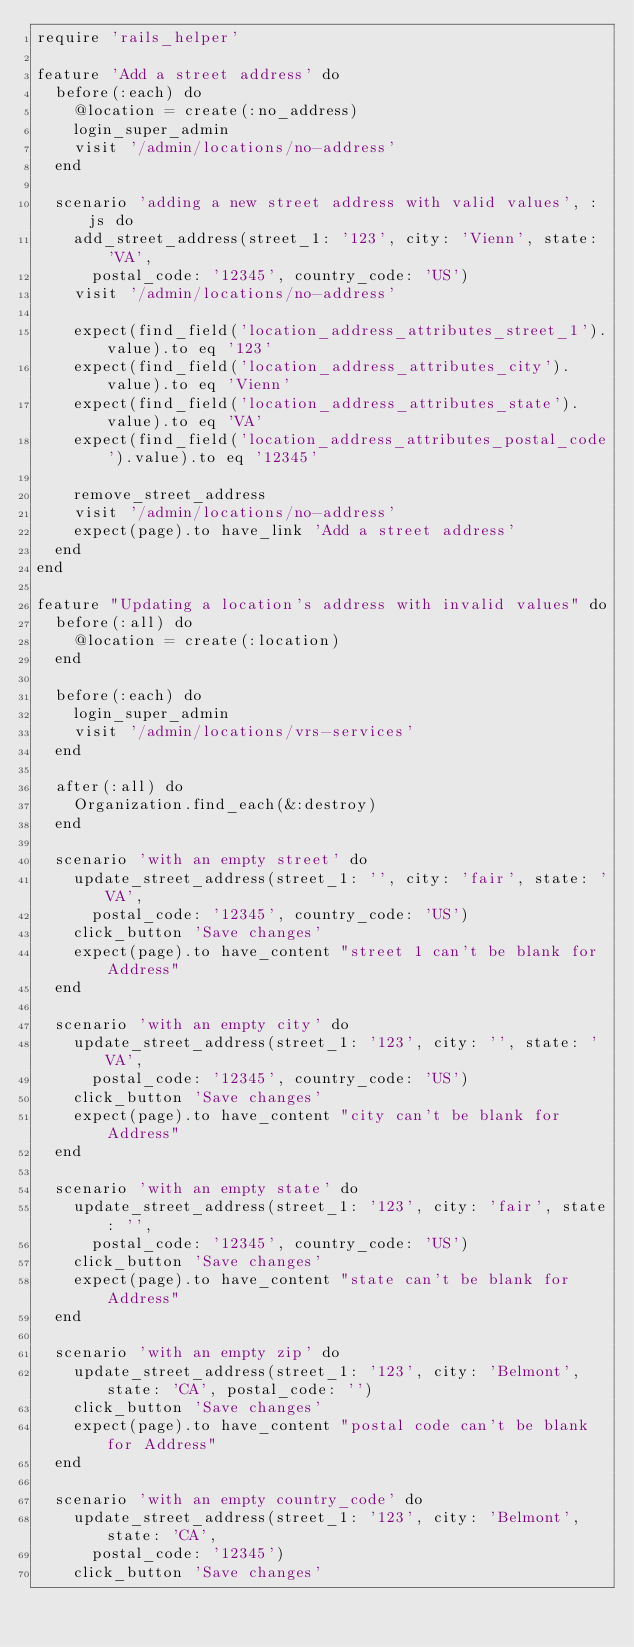Convert code to text. <code><loc_0><loc_0><loc_500><loc_500><_Ruby_>require 'rails_helper'

feature 'Add a street address' do
  before(:each) do
    @location = create(:no_address)
    login_super_admin
    visit '/admin/locations/no-address'
  end

  scenario 'adding a new street address with valid values', :js do
    add_street_address(street_1: '123', city: 'Vienn', state: 'VA',
      postal_code: '12345', country_code: 'US')
    visit '/admin/locations/no-address'

    expect(find_field('location_address_attributes_street_1').value).to eq '123'
    expect(find_field('location_address_attributes_city').value).to eq 'Vienn'
    expect(find_field('location_address_attributes_state').value).to eq 'VA'
    expect(find_field('location_address_attributes_postal_code').value).to eq '12345'

    remove_street_address
    visit '/admin/locations/no-address'
    expect(page).to have_link 'Add a street address'
  end
end

feature "Updating a location's address with invalid values" do
  before(:all) do
    @location = create(:location)
  end

  before(:each) do
    login_super_admin
    visit '/admin/locations/vrs-services'
  end

  after(:all) do
    Organization.find_each(&:destroy)
  end

  scenario 'with an empty street' do
    update_street_address(street_1: '', city: 'fair', state: 'VA',
      postal_code: '12345', country_code: 'US')
    click_button 'Save changes'
    expect(page).to have_content "street 1 can't be blank for Address"
  end

  scenario 'with an empty city' do
    update_street_address(street_1: '123', city: '', state: 'VA',
      postal_code: '12345', country_code: 'US')
    click_button 'Save changes'
    expect(page).to have_content "city can't be blank for Address"
  end

  scenario 'with an empty state' do
    update_street_address(street_1: '123', city: 'fair', state: '',
      postal_code: '12345', country_code: 'US')
    click_button 'Save changes'
    expect(page).to have_content "state can't be blank for Address"
  end

  scenario 'with an empty zip' do
    update_street_address(street_1: '123', city: 'Belmont', state: 'CA', postal_code: '')
    click_button 'Save changes'
    expect(page).to have_content "postal code can't be blank for Address"
  end

  scenario 'with an empty country_code' do
    update_street_address(street_1: '123', city: 'Belmont', state: 'CA',
      postal_code: '12345')
    click_button 'Save changes'</code> 